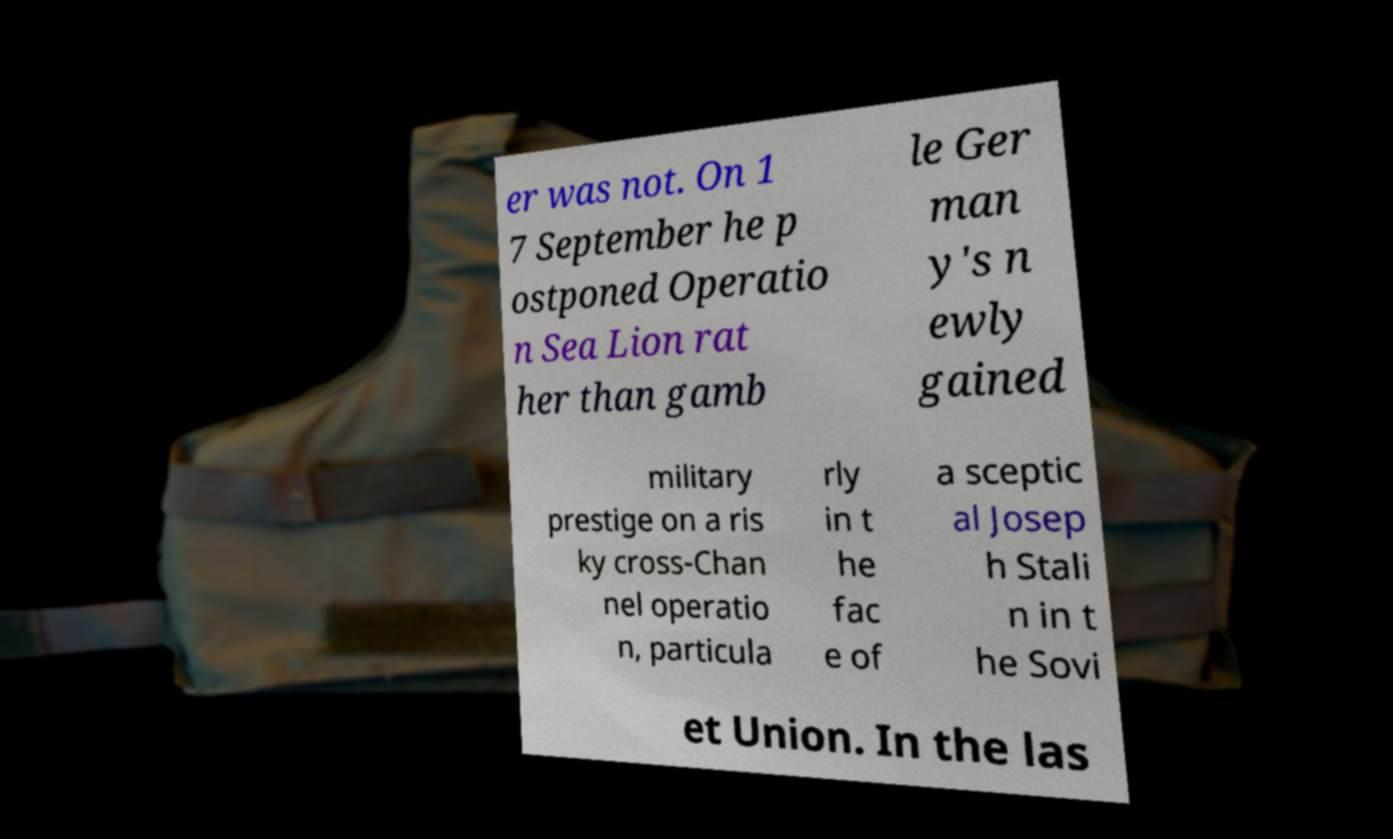Could you assist in decoding the text presented in this image and type it out clearly? er was not. On 1 7 September he p ostponed Operatio n Sea Lion rat her than gamb le Ger man y's n ewly gained military prestige on a ris ky cross-Chan nel operatio n, particula rly in t he fac e of a sceptic al Josep h Stali n in t he Sovi et Union. In the las 